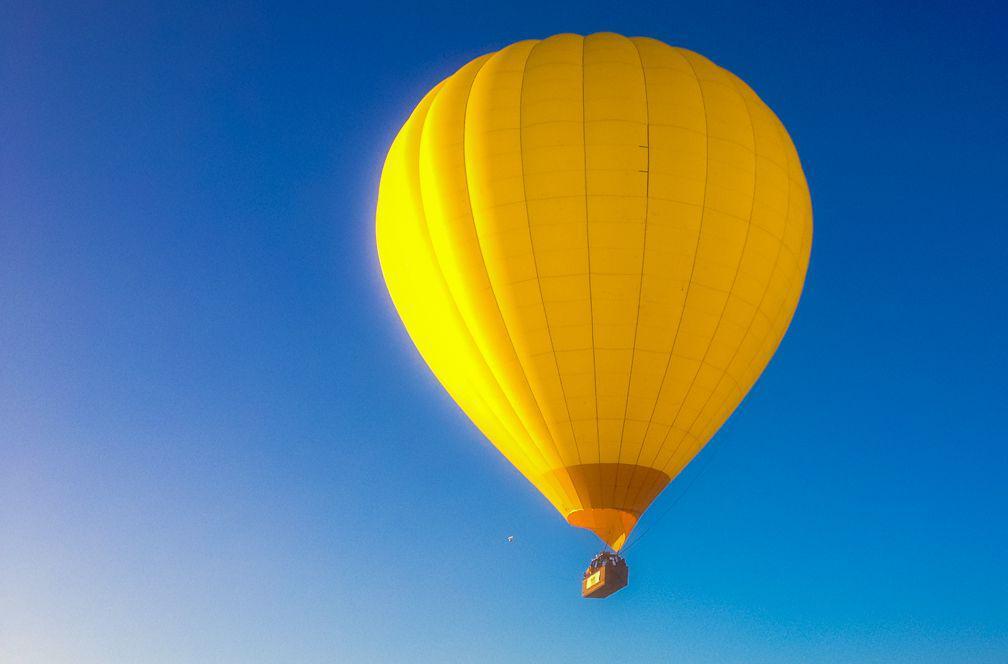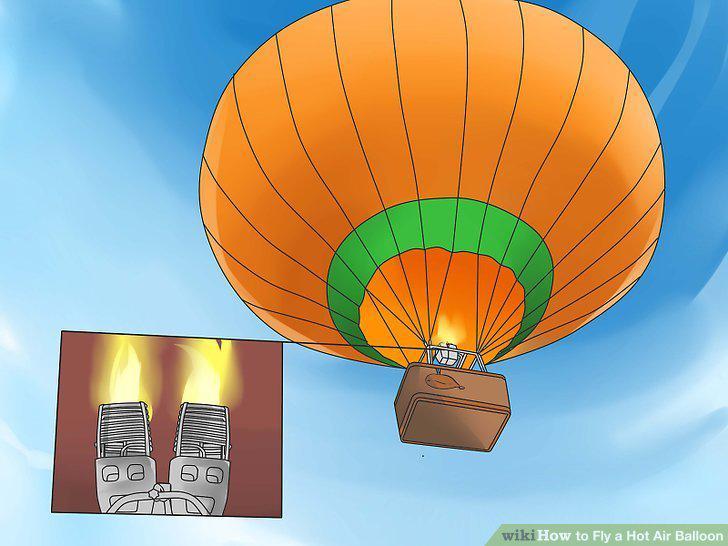The first image is the image on the left, the second image is the image on the right. Considering the images on both sides, is "Two hot air balloons are predominantly red and have baskets for passengers." valid? Answer yes or no. No. 